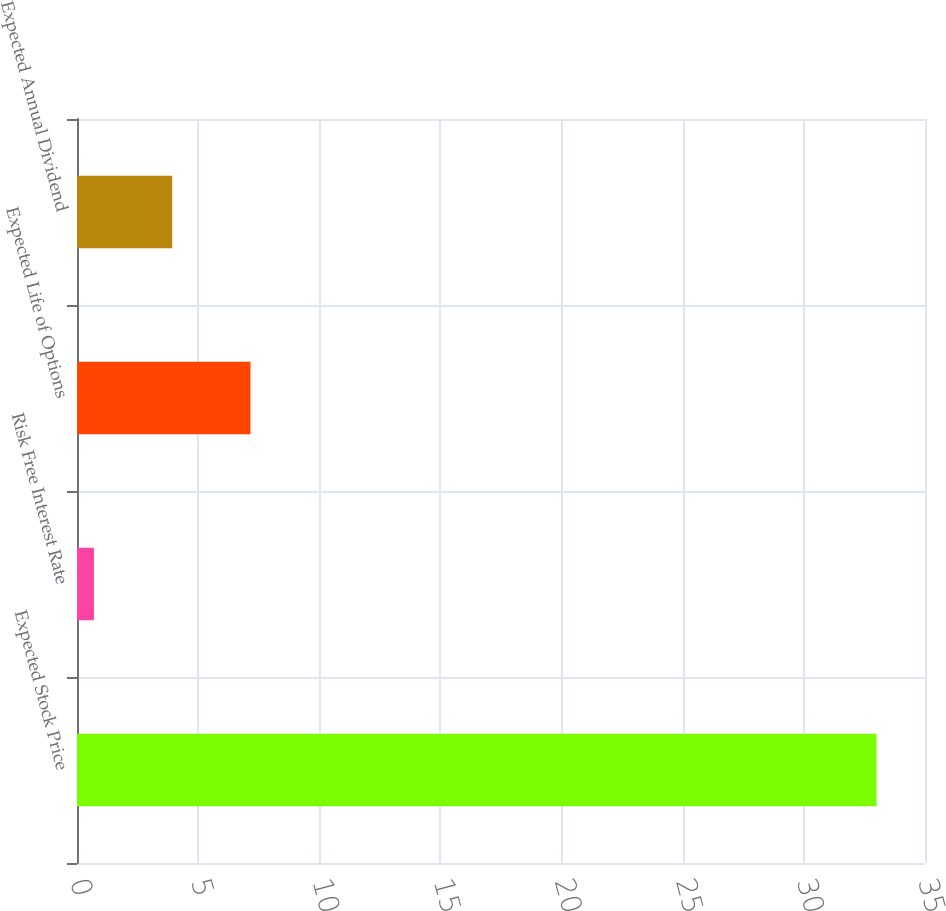Convert chart. <chart><loc_0><loc_0><loc_500><loc_500><bar_chart><fcel>Expected Stock Price<fcel>Risk Free Interest Rate<fcel>Expected Life of Options<fcel>Expected Annual Dividend<nl><fcel>33<fcel>0.7<fcel>7.16<fcel>3.93<nl></chart> 